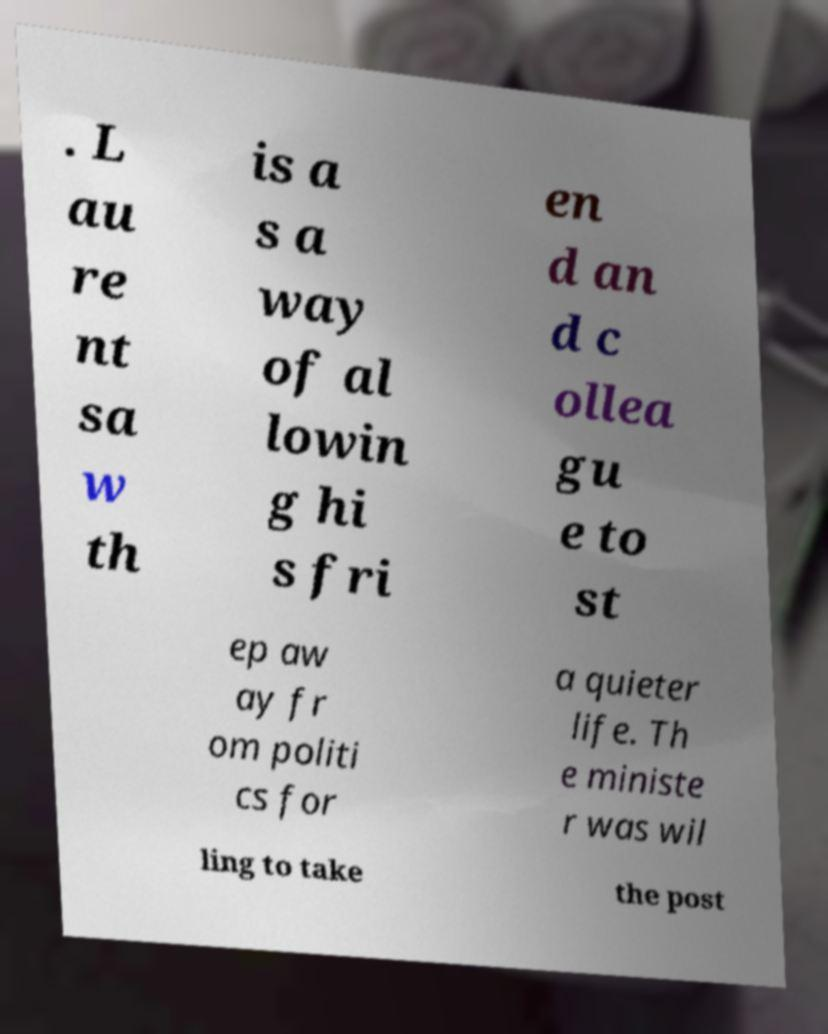I need the written content from this picture converted into text. Can you do that? . L au re nt sa w th is a s a way of al lowin g hi s fri en d an d c ollea gu e to st ep aw ay fr om politi cs for a quieter life. Th e ministe r was wil ling to take the post 